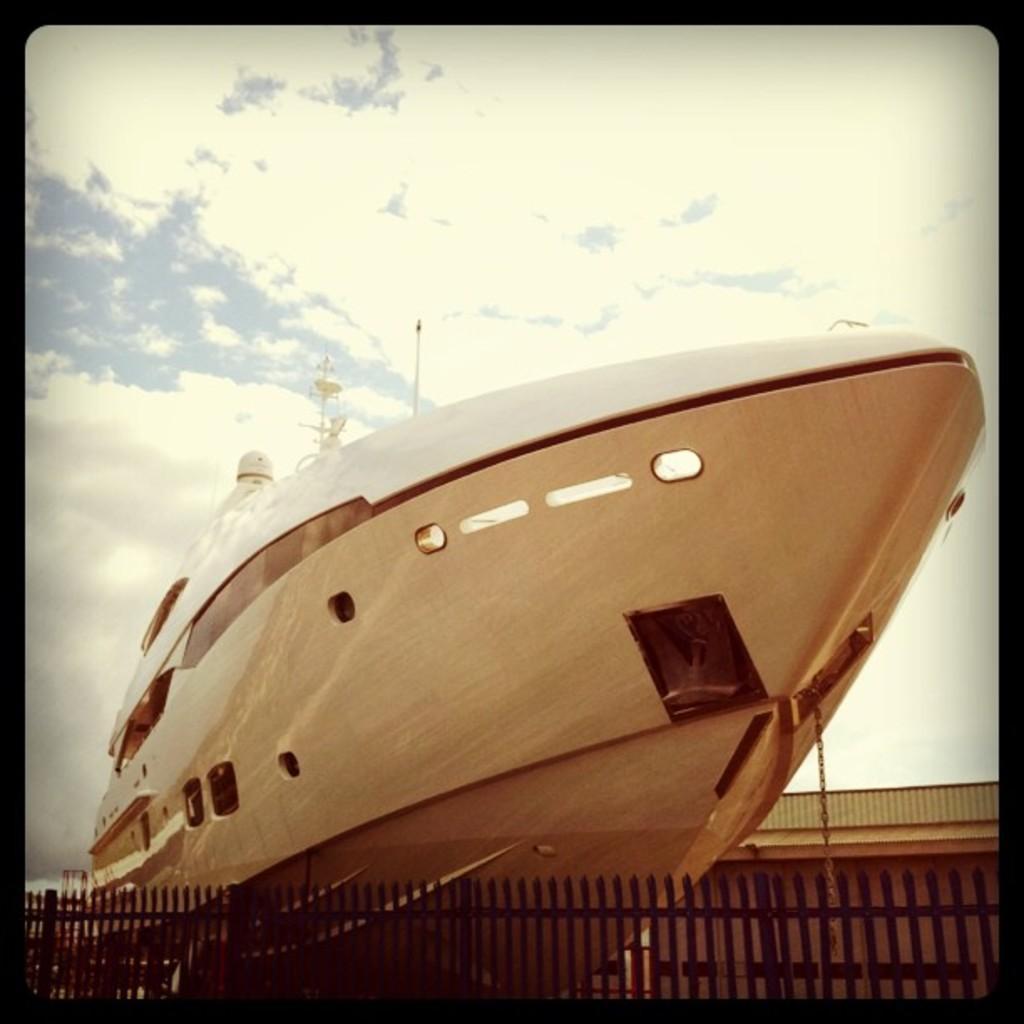Describe this image in one or two sentences. In this image we can see the motor boat. And we can see the wooden fencing. And we can see the clouds in the sky. 